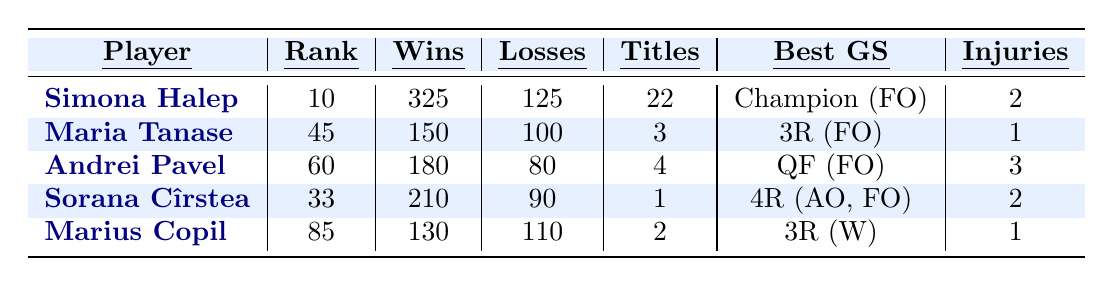What is the highest world ranking achieved by any Romanian player in the last five years? The table shows that Simona Halep has the highest world ranking of 10 among the listed players.
Answer: 10 How many titles has Andrei Pavel won? According to the table, Andrei Pavel has won 4 titles.
Answer: 4 Which player has the fewest matches lost? By examining the "Losses" column, Sorana Cîrstea has 90 losses, the fewest of all players listed.
Answer: 90 What is the total number of titles won by the players in the table? The titles won are 22 (Halep) + 3 (Tanase) + 4 (Pavel) + 1 (Cîrstea) + 2 (Copil) = 32 titles.
Answer: 32 Did any player among the listed ones not suffer any injuries? All players have injury incidents, as there is no entry with 0 injuries in the table.
Answer: No Who has the best performance at the French Open? The best achievement at the French Open is shown under "Best GS" as "Champion (FO)" for Simona Halep.
Answer: Simona Halep What is the average number of wins among all players listed? The total number of wins is 325 (Halep) + 150 (Tanase) + 180 (Pavel) + 210 (Cîrstea) + 130 (Copil) = 1095. There are 5 players; therefore, the average is 1095 / 5 = 219.
Answer: 219 Which player has the most injury incidents? The table indicates that Andrei Pavel has the most injury incidents, with a total of 3.
Answer: 3 How many more matches has Simona Halep won than Maria Tanase? Simona Halep won 325 matches, while Maria Tanase won 150. The difference is 325 - 150 = 175 matches.
Answer: 175 Is it true that Marius Copil has a better career win-loss ratio than Sorana Cîrstea? To find the win-loss ratio, divide wins by losses for both players. Halep: 325/125 = 2.6, Tanase: 150/100 = 1.5, Pavel: 180/80 = 2.25, Cîrstea: 210/90 = 2.33, Copil: 130/110 = 1.18. Sorana Cîrstea has a better ratio than Marius Copil.
Answer: No 